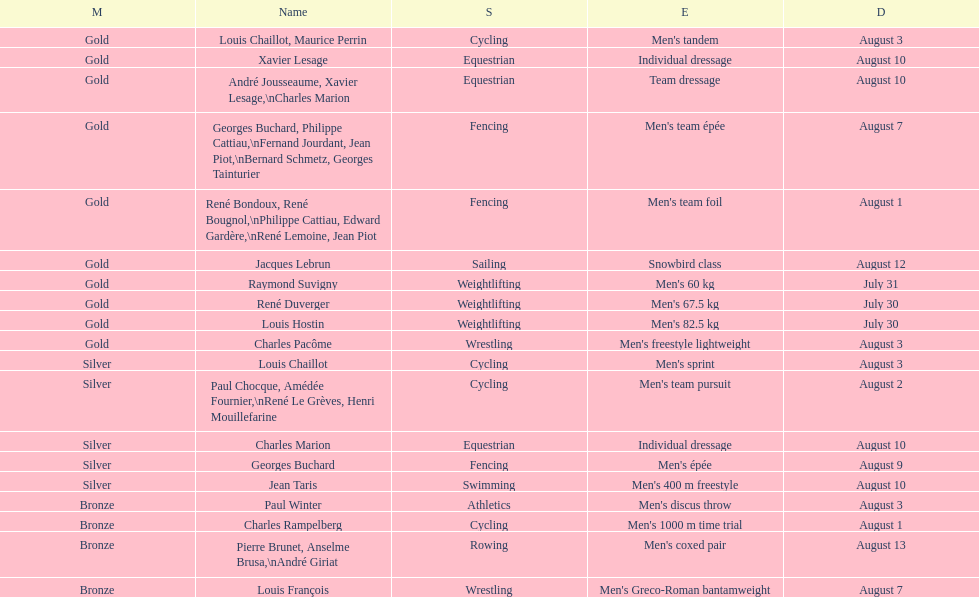How many gold medals did this country win during these olympics? 10. 